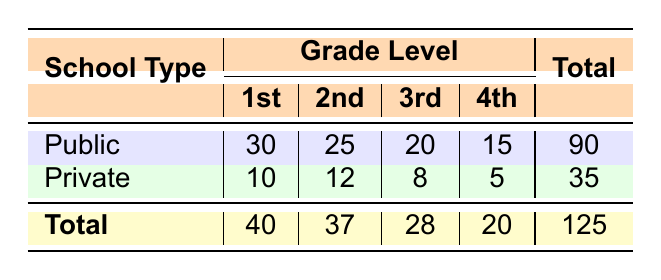What is the total attendance frequency for public schools? To find the total attendance frequency for public schools, we sum the attendance frequencies for each grade level under the public category: 30 (1st) + 25 (2nd) + 20 (3rd) + 15 (4th) = 90.
Answer: 90 Which grade level had the highest attendance frequency for private schools? By checking the attendance frequencies for private schools at each grade level, we find: 10 (1st), 12 (2nd), 8 (3rd), and 5 (4th). The highest frequency is 12 for the 2nd grade.
Answer: 2nd Grade What is the average attendance frequency across all grade levels for public schools? To calculate the average, sum the attendance frequencies for public schools: 30 + 25 + 20 + 15 = 90, and divide by the number of grades (4): 90 / 4 = 22.5.
Answer: 22.5 Is the total attendance frequency for public schools greater than that for private schools? The total for public schools is 90, and for private schools it is 35. Since 90 is greater than 35, the statement is true.
Answer: Yes What is the difference in attendance frequency between the 1st and 4th grades for public schools? We find the attendance frequencies for 1st and 4th grades under public schools: 30 (1st) and 15 (4th). The difference is 30 - 15 = 15.
Answer: 15 How many more students attended the 1st grade compared to the 3rd grade in public schools? The attendance for public schools is 30 for the 1st grade and 20 for the 3rd grade. The difference is 30 - 20 = 10.
Answer: 10 Are there more students in total from public schools than private schools? The totals are 90 for public schools and 35 for private schools. Since 90 is greater than 35, the statement is true.
Answer: Yes What percentage of total attendance is represented by private school attendance? The total attendance across both school types is 125 (90 public + 35 private). To find the percentage for private schools, divide 35 by 125 and multiply by 100, resulting in (35/125) * 100 = 28%.
Answer: 28% 